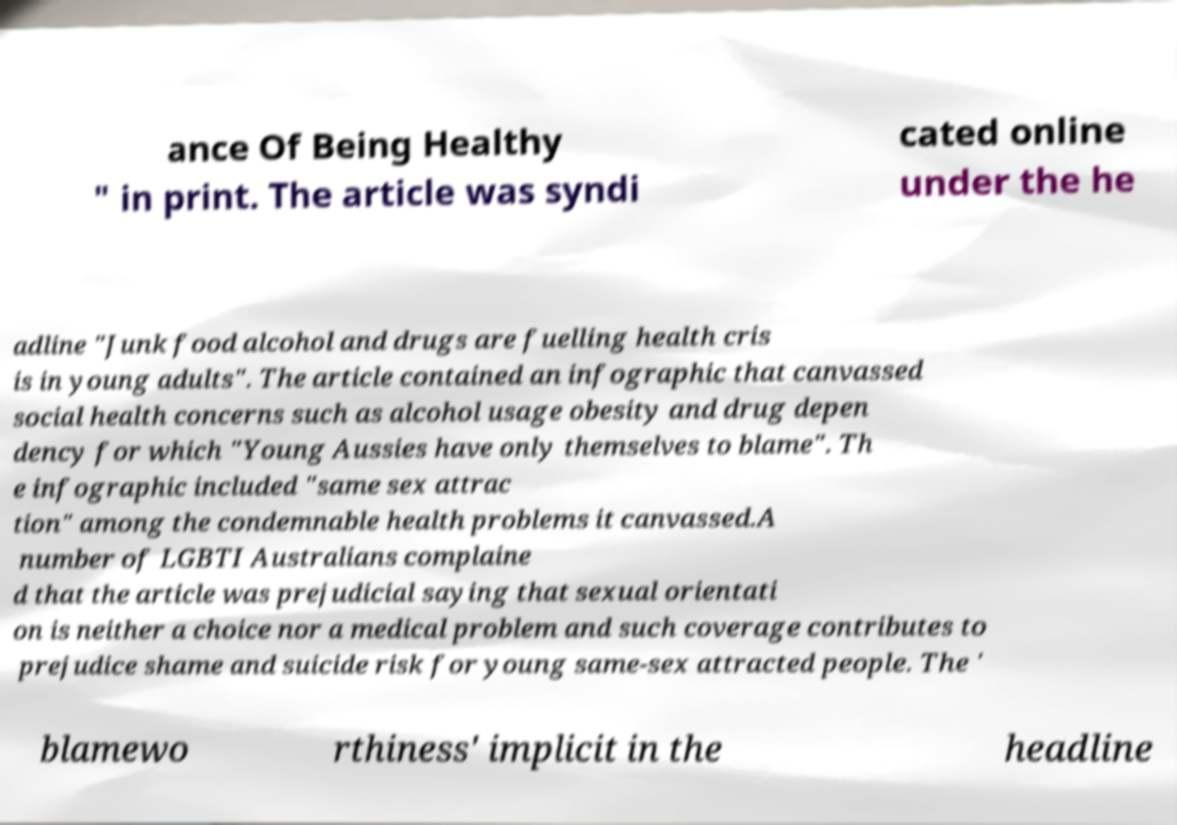Can you read and provide the text displayed in the image?This photo seems to have some interesting text. Can you extract and type it out for me? ance Of Being Healthy " in print. The article was syndi cated online under the he adline "Junk food alcohol and drugs are fuelling health cris is in young adults". The article contained an infographic that canvassed social health concerns such as alcohol usage obesity and drug depen dency for which "Young Aussies have only themselves to blame". Th e infographic included "same sex attrac tion" among the condemnable health problems it canvassed.A number of LGBTI Australians complaine d that the article was prejudicial saying that sexual orientati on is neither a choice nor a medical problem and such coverage contributes to prejudice shame and suicide risk for young same-sex attracted people. The ' blamewo rthiness' implicit in the headline 